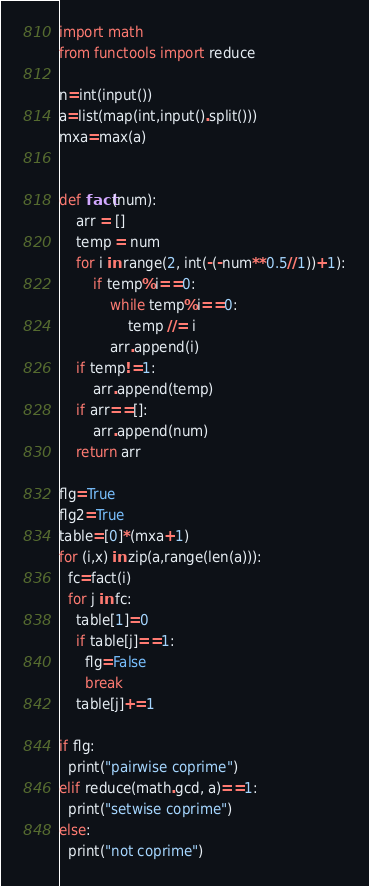<code> <loc_0><loc_0><loc_500><loc_500><_Python_>import math
from functools import reduce

n=int(input())
a=list(map(int,input().split()))
mxa=max(a)

            
def fact(num):
    arr = []
    temp = num
    for i in range(2, int(-(-num**0.5//1))+1):
        if temp%i==0:
            while temp%i==0:
                temp //= i
            arr.append(i)
    if temp!=1:
        arr.append(temp)
    if arr==[]:
        arr.append(num)
    return arr

flg=True
flg2=True
table=[0]*(mxa+1)
for (i,x) in zip(a,range(len(a))):
  fc=fact(i)
  for j in fc:
    table[1]=0
    if table[j]==1:
      flg=False
      break
    table[j]+=1

if flg:
  print("pairwise coprime")
elif reduce(math.gcd, a)==1:
  print("setwise coprime")
else:
  print("not coprime")

</code> 